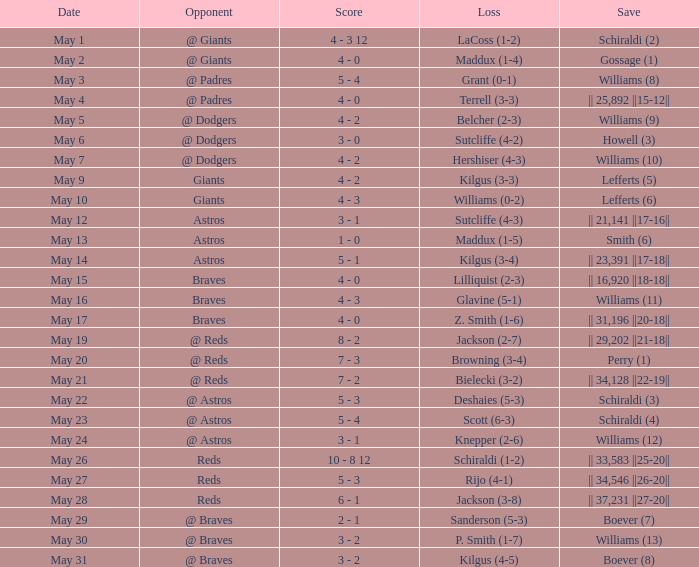Name the save for braves for may 15 || 16,920 ||18-18||. 